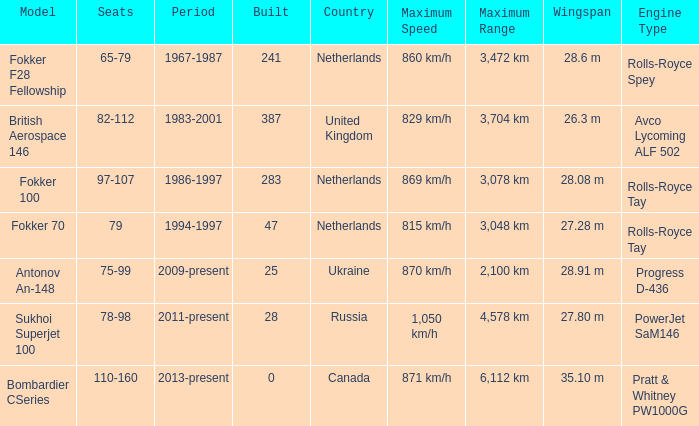Between which years were there 241 fokker 70 model cabins built? 1994-1997. 